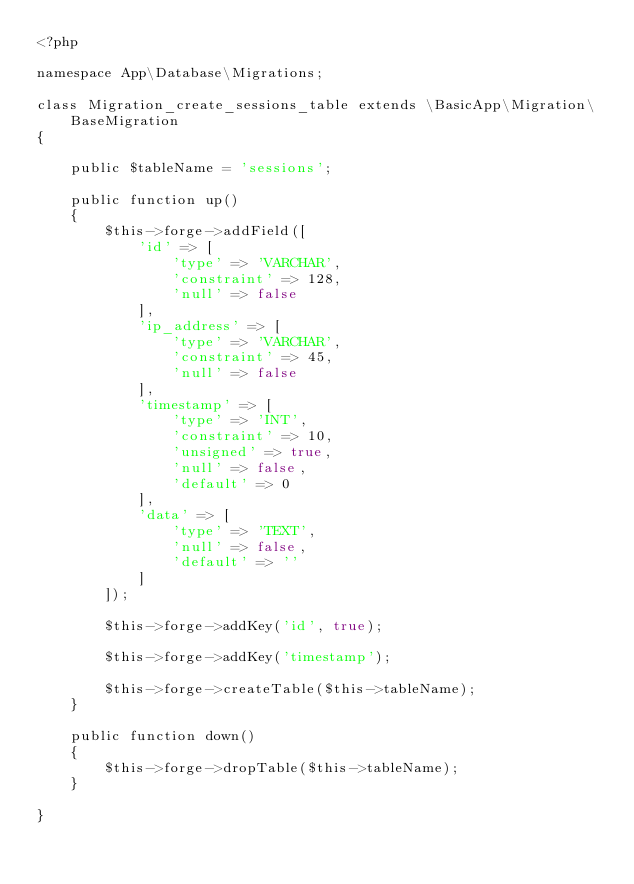Convert code to text. <code><loc_0><loc_0><loc_500><loc_500><_PHP_><?php

namespace App\Database\Migrations;

class Migration_create_sessions_table extends \BasicApp\Migration\BaseMigration
{

    public $tableName = 'sessions';

    public function up()
    {
        $this->forge->addField([
            'id' => [
                'type' => 'VARCHAR',
                'constraint' => 128,
                'null' => false
            ],
            'ip_address' => [
                'type' => 'VARCHAR',
                'constraint' => 45,
                'null' => false
            ],
            'timestamp' => [
                'type' => 'INT',
                'constraint' => 10,
                'unsigned' => true,
                'null' => false,
                'default' => 0
            ],
            'data' => [
                'type' => 'TEXT',
                'null' => false,
                'default' => ''
            ]
        ]);

        $this->forge->addKey('id', true);

        $this->forge->addKey('timestamp');

        $this->forge->createTable($this->tableName);
    }

    public function down()
    {
        $this->forge->dropTable($this->tableName);
    }

}</code> 